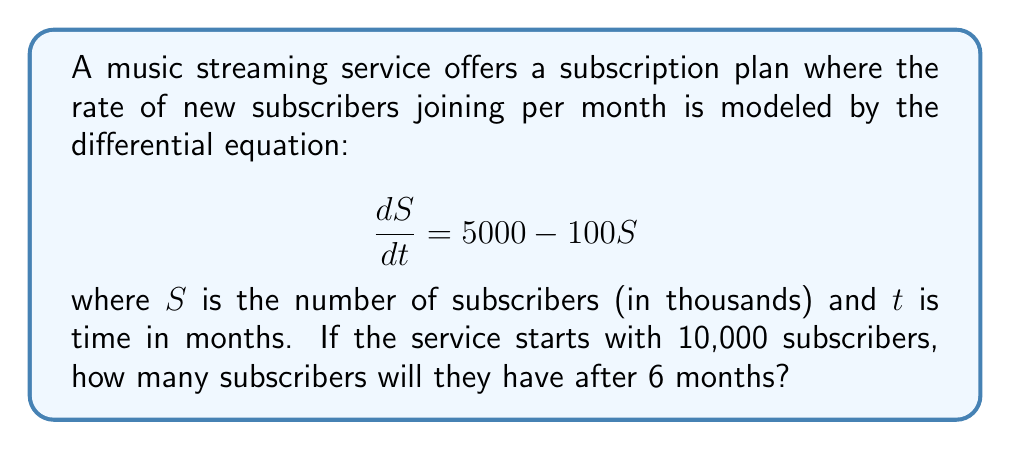Could you help me with this problem? To solve this problem, we need to use the method for solving first-order linear differential equations.

1) The general form of a first-order linear differential equation is:

   $$\frac{dy}{dx} + P(x)y = Q(x)$$

2) In our case, we have:

   $$\frac{dS}{dt} = 5000 - 100S$$

   This can be rewritten as:

   $$\frac{dS}{dt} + 100S = 5000$$

3) Here, $P(t) = 100$ and $Q(t) = 5000$

4) The general solution to this type of equation is:

   $$y = e^{-\int P(x)dx} \left(\int Q(x)e^{\int P(x)dx}dx + C\right)$$

5) In our case:

   $$S = e^{-\int 100dt} \left(\int 5000e^{\int 100dt}dt + C\right)$$

6) Solving the integrals:

   $$S = e^{-100t} \left(\int 5000e^{100t}dt + C\right)$$
   $$S = e^{-100t} \left(\frac{5000}{100}e^{100t} + C\right)$$
   $$S = 50 + Ce^{-100t}$$

7) To find C, we use the initial condition: $S(0) = 10$ (remember, S is in thousands)

   $$10 = 50 + C$$
   $$C = -40$$

8) So our particular solution is:

   $$S = 50 - 40e^{-100t}$$

9) To find the number of subscribers after 6 months, we substitute $t = 6$:

   $$S(6) = 50 - 40e^{-100(6)}$$
   $$S(6) = 50 - 40e^{-600}$$
   $$S(6) \approx 50$$ (as $e^{-600}$ is essentially zero)

10) Remember to convert back to actual number of subscribers:

    $50,000$ subscribers
Answer: After 6 months, the music streaming service will have approximately 50,000 subscribers. 